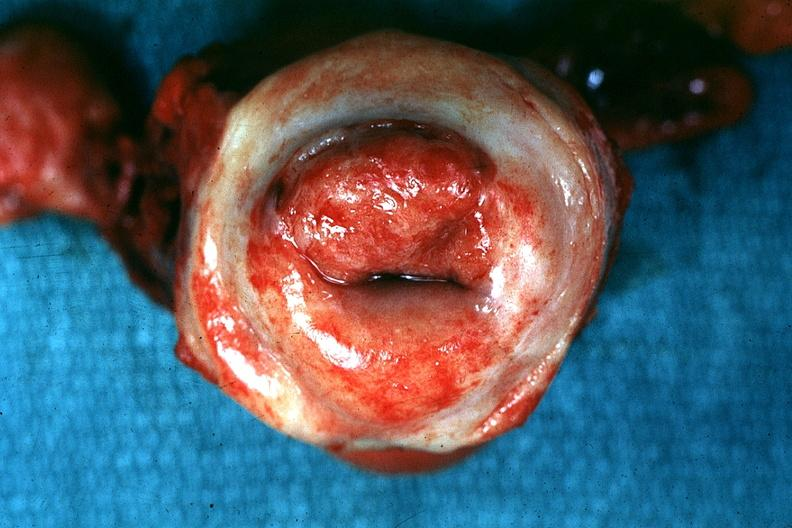s female reproductive present?
Answer the question using a single word or phrase. Yes 